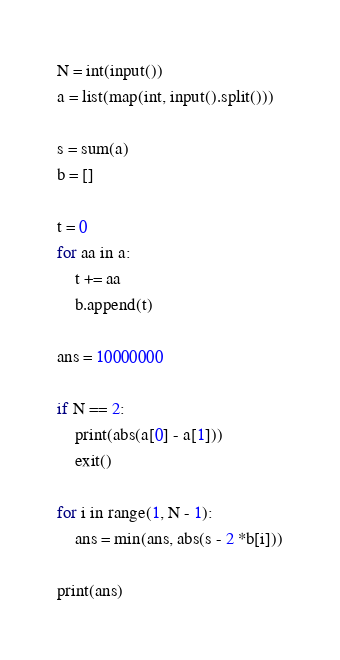Convert code to text. <code><loc_0><loc_0><loc_500><loc_500><_Python_>N = int(input())
a = list(map(int, input().split()))

s = sum(a)
b = []

t = 0
for aa in a:
    t += aa
    b.append(t)

ans = 10000000

if N == 2:
    print(abs(a[0] - a[1]))
    exit()

for i in range(1, N - 1):
    ans = min(ans, abs(s - 2 *b[i]))

print(ans)
</code> 